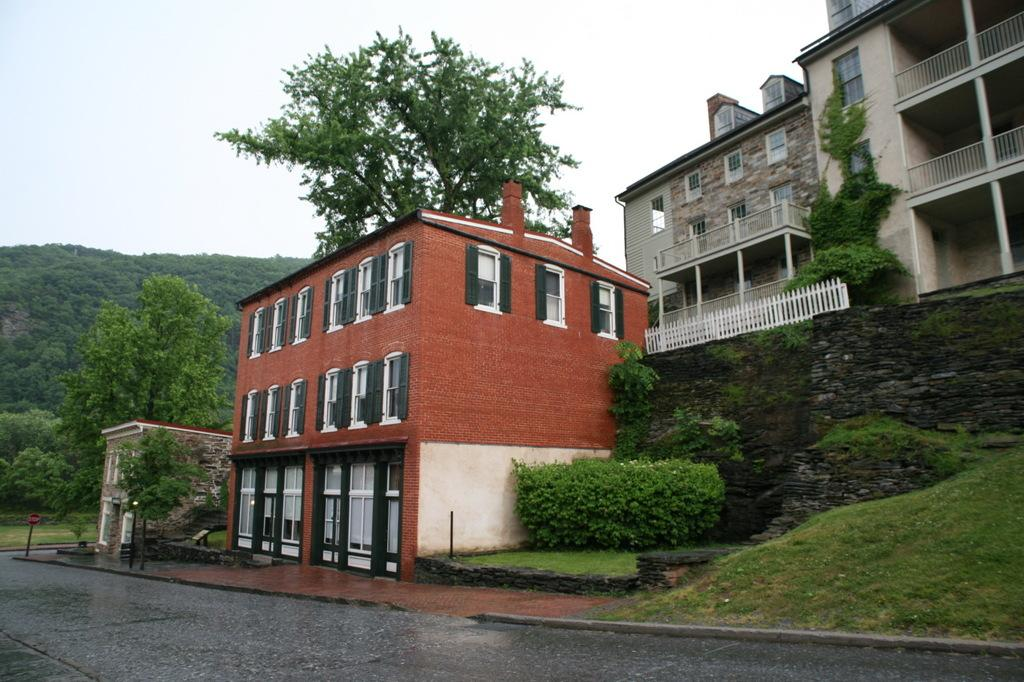What is the main feature of the image? There is a road in the image. What else can be seen in the image besides the road? There are trees and buildings with windows in the image. What is visible in the background of the image? The sky is visible in the background of the image. Where are the cherries placed in the image? There are no cherries present in the image. What type of ink is used to write on the buildings in the image? There is no writing on the buildings in the image, so it is not possible to determine the type of ink used. 